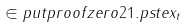Convert formula to latex. <formula><loc_0><loc_0><loc_500><loc_500>\in p u t { p r o o f z e r o 2 1 . p s t e x _ { t } }</formula> 